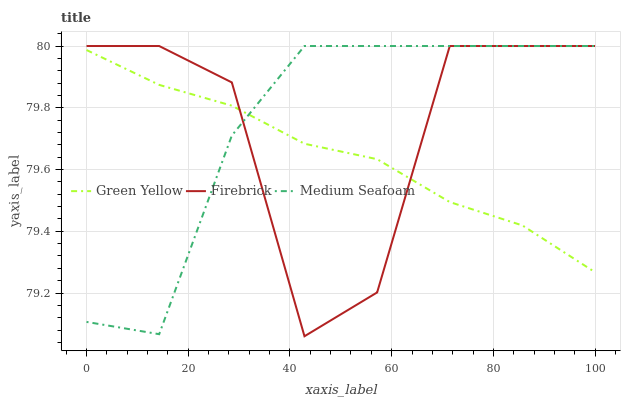Does Green Yellow have the minimum area under the curve?
Answer yes or no. Yes. Does Medium Seafoam have the minimum area under the curve?
Answer yes or no. No. Does Green Yellow have the maximum area under the curve?
Answer yes or no. No. Is Firebrick the roughest?
Answer yes or no. Yes. Is Medium Seafoam the smoothest?
Answer yes or no. No. Is Medium Seafoam the roughest?
Answer yes or no. No. Does Medium Seafoam have the lowest value?
Answer yes or no. No. Does Green Yellow have the highest value?
Answer yes or no. No. 